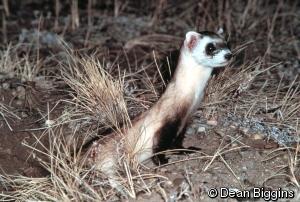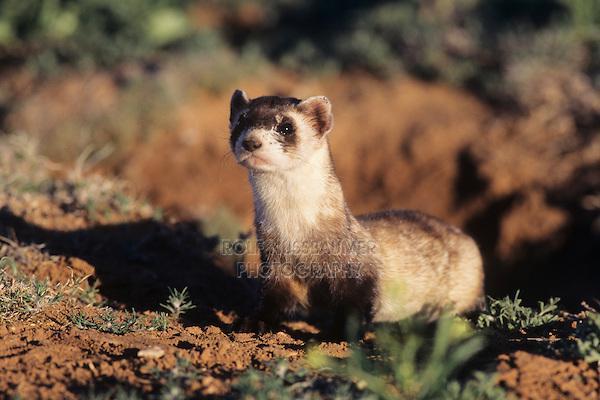The first image is the image on the left, the second image is the image on the right. For the images displayed, is the sentence "In one of the images, the weasel's body is turned to the right, and in the other, it's turned to the left." factually correct? Answer yes or no. Yes. The first image is the image on the left, the second image is the image on the right. Assess this claim about the two images: "ferrets are laying down and facing the camera". Correct or not? Answer yes or no. No. 